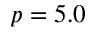Convert formula to latex. <formula><loc_0><loc_0><loc_500><loc_500>p = 5 . 0</formula> 